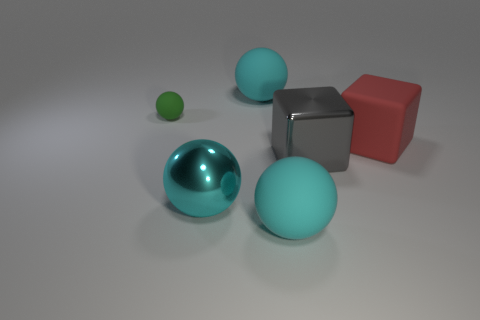There is a green object that is the same material as the big red thing; what shape is it?
Offer a very short reply. Sphere. Is there any other thing of the same color as the shiny sphere?
Your answer should be very brief. Yes. What color is the big sphere right of the cyan thing that is behind the red object?
Offer a terse response. Cyan. What number of big things are either green rubber things or rubber things?
Provide a short and direct response. 3. What material is the green thing that is the same shape as the big cyan metallic thing?
Provide a short and direct response. Rubber. Is there anything else that is the same material as the small green sphere?
Ensure brevity in your answer.  Yes. What is the color of the tiny matte ball?
Offer a terse response. Green. Do the small sphere and the big shiny sphere have the same color?
Provide a succinct answer. No. There is a big rubber sphere in front of the large red rubber object; how many big matte spheres are left of it?
Offer a terse response. 1. There is a rubber object that is in front of the tiny green object and left of the large gray metal thing; what is its size?
Provide a succinct answer. Large. 